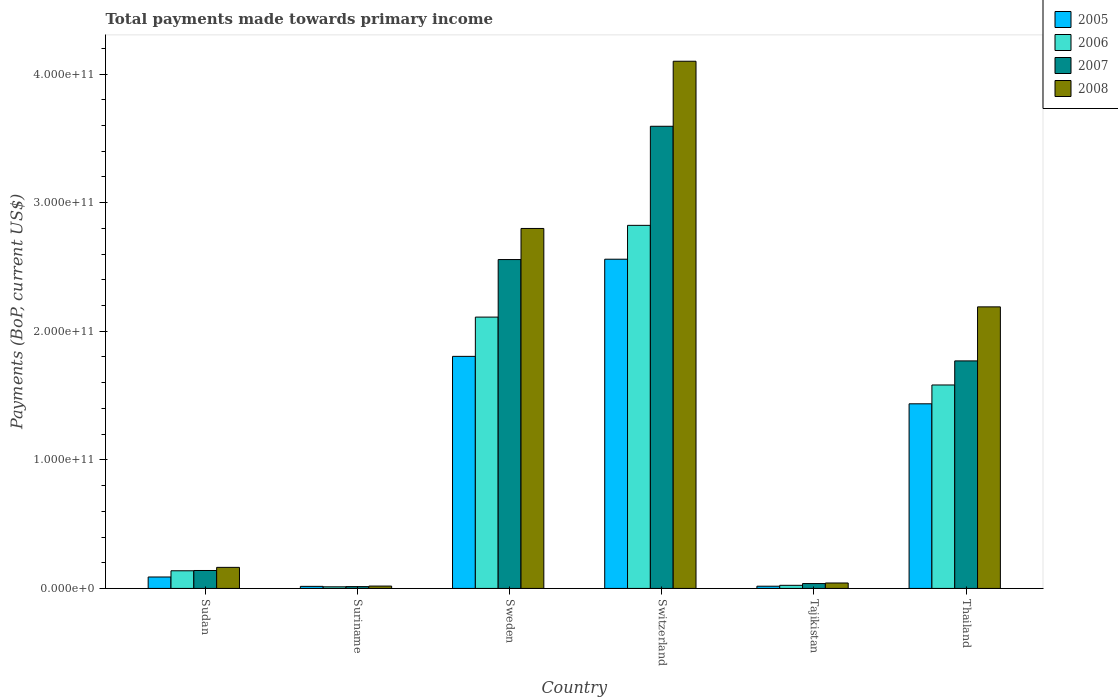Are the number of bars per tick equal to the number of legend labels?
Make the answer very short. Yes. Are the number of bars on each tick of the X-axis equal?
Provide a short and direct response. Yes. How many bars are there on the 2nd tick from the right?
Keep it short and to the point. 4. What is the label of the 4th group of bars from the left?
Ensure brevity in your answer.  Switzerland. In how many cases, is the number of bars for a given country not equal to the number of legend labels?
Your answer should be compact. 0. What is the total payments made towards primary income in 2006 in Tajikistan?
Ensure brevity in your answer.  2.43e+09. Across all countries, what is the maximum total payments made towards primary income in 2008?
Offer a very short reply. 4.10e+11. Across all countries, what is the minimum total payments made towards primary income in 2005?
Offer a terse response. 1.61e+09. In which country was the total payments made towards primary income in 2007 maximum?
Your answer should be compact. Switzerland. In which country was the total payments made towards primary income in 2006 minimum?
Provide a succinct answer. Suriname. What is the total total payments made towards primary income in 2007 in the graph?
Give a very brief answer. 8.11e+11. What is the difference between the total payments made towards primary income in 2008 in Sudan and that in Sweden?
Your response must be concise. -2.64e+11. What is the difference between the total payments made towards primary income in 2007 in Sudan and the total payments made towards primary income in 2006 in Tajikistan?
Keep it short and to the point. 1.15e+1. What is the average total payments made towards primary income in 2008 per country?
Make the answer very short. 1.55e+11. What is the difference between the total payments made towards primary income of/in 2005 and total payments made towards primary income of/in 2007 in Tajikistan?
Provide a short and direct response. -2.05e+09. In how many countries, is the total payments made towards primary income in 2008 greater than 360000000000 US$?
Ensure brevity in your answer.  1. What is the ratio of the total payments made towards primary income in 2005 in Sudan to that in Suriname?
Keep it short and to the point. 5.54. Is the total payments made towards primary income in 2006 in Sweden less than that in Switzerland?
Make the answer very short. Yes. Is the difference between the total payments made towards primary income in 2005 in Sudan and Tajikistan greater than the difference between the total payments made towards primary income in 2007 in Sudan and Tajikistan?
Ensure brevity in your answer.  No. What is the difference between the highest and the second highest total payments made towards primary income in 2008?
Ensure brevity in your answer.  1.30e+11. What is the difference between the highest and the lowest total payments made towards primary income in 2005?
Ensure brevity in your answer.  2.54e+11. Is the sum of the total payments made towards primary income in 2005 in Switzerland and Thailand greater than the maximum total payments made towards primary income in 2006 across all countries?
Your answer should be compact. Yes. What does the 4th bar from the left in Thailand represents?
Your answer should be compact. 2008. Is it the case that in every country, the sum of the total payments made towards primary income in 2005 and total payments made towards primary income in 2007 is greater than the total payments made towards primary income in 2008?
Keep it short and to the point. Yes. How many bars are there?
Offer a very short reply. 24. What is the difference between two consecutive major ticks on the Y-axis?
Give a very brief answer. 1.00e+11. Are the values on the major ticks of Y-axis written in scientific E-notation?
Your response must be concise. Yes. How are the legend labels stacked?
Your answer should be very brief. Vertical. What is the title of the graph?
Give a very brief answer. Total payments made towards primary income. Does "2000" appear as one of the legend labels in the graph?
Provide a succinct answer. No. What is the label or title of the Y-axis?
Give a very brief answer. Payments (BoP, current US$). What is the Payments (BoP, current US$) of 2005 in Sudan?
Your answer should be compact. 8.90e+09. What is the Payments (BoP, current US$) in 2006 in Sudan?
Your response must be concise. 1.37e+1. What is the Payments (BoP, current US$) of 2007 in Sudan?
Make the answer very short. 1.40e+1. What is the Payments (BoP, current US$) in 2008 in Sudan?
Your response must be concise. 1.64e+1. What is the Payments (BoP, current US$) in 2005 in Suriname?
Give a very brief answer. 1.61e+09. What is the Payments (BoP, current US$) in 2006 in Suriname?
Your answer should be very brief. 1.25e+09. What is the Payments (BoP, current US$) in 2007 in Suriname?
Your answer should be compact. 1.41e+09. What is the Payments (BoP, current US$) of 2008 in Suriname?
Give a very brief answer. 1.84e+09. What is the Payments (BoP, current US$) of 2005 in Sweden?
Your response must be concise. 1.80e+11. What is the Payments (BoP, current US$) of 2006 in Sweden?
Provide a short and direct response. 2.11e+11. What is the Payments (BoP, current US$) in 2007 in Sweden?
Your response must be concise. 2.56e+11. What is the Payments (BoP, current US$) in 2008 in Sweden?
Provide a short and direct response. 2.80e+11. What is the Payments (BoP, current US$) in 2005 in Switzerland?
Offer a very short reply. 2.56e+11. What is the Payments (BoP, current US$) in 2006 in Switzerland?
Ensure brevity in your answer.  2.82e+11. What is the Payments (BoP, current US$) in 2007 in Switzerland?
Keep it short and to the point. 3.59e+11. What is the Payments (BoP, current US$) of 2008 in Switzerland?
Your response must be concise. 4.10e+11. What is the Payments (BoP, current US$) of 2005 in Tajikistan?
Ensure brevity in your answer.  1.73e+09. What is the Payments (BoP, current US$) in 2006 in Tajikistan?
Offer a very short reply. 2.43e+09. What is the Payments (BoP, current US$) of 2007 in Tajikistan?
Provide a short and direct response. 3.78e+09. What is the Payments (BoP, current US$) in 2008 in Tajikistan?
Your answer should be compact. 4.23e+09. What is the Payments (BoP, current US$) in 2005 in Thailand?
Your response must be concise. 1.44e+11. What is the Payments (BoP, current US$) of 2006 in Thailand?
Offer a terse response. 1.58e+11. What is the Payments (BoP, current US$) of 2007 in Thailand?
Ensure brevity in your answer.  1.77e+11. What is the Payments (BoP, current US$) in 2008 in Thailand?
Give a very brief answer. 2.19e+11. Across all countries, what is the maximum Payments (BoP, current US$) in 2005?
Your response must be concise. 2.56e+11. Across all countries, what is the maximum Payments (BoP, current US$) in 2006?
Provide a succinct answer. 2.82e+11. Across all countries, what is the maximum Payments (BoP, current US$) in 2007?
Offer a terse response. 3.59e+11. Across all countries, what is the maximum Payments (BoP, current US$) of 2008?
Your answer should be very brief. 4.10e+11. Across all countries, what is the minimum Payments (BoP, current US$) in 2005?
Provide a succinct answer. 1.61e+09. Across all countries, what is the minimum Payments (BoP, current US$) in 2006?
Your answer should be compact. 1.25e+09. Across all countries, what is the minimum Payments (BoP, current US$) in 2007?
Provide a succinct answer. 1.41e+09. Across all countries, what is the minimum Payments (BoP, current US$) in 2008?
Make the answer very short. 1.84e+09. What is the total Payments (BoP, current US$) in 2005 in the graph?
Give a very brief answer. 5.92e+11. What is the total Payments (BoP, current US$) in 2006 in the graph?
Give a very brief answer. 6.69e+11. What is the total Payments (BoP, current US$) of 2007 in the graph?
Your response must be concise. 8.11e+11. What is the total Payments (BoP, current US$) in 2008 in the graph?
Keep it short and to the point. 9.31e+11. What is the difference between the Payments (BoP, current US$) in 2005 in Sudan and that in Suriname?
Offer a terse response. 7.29e+09. What is the difference between the Payments (BoP, current US$) of 2006 in Sudan and that in Suriname?
Provide a short and direct response. 1.25e+1. What is the difference between the Payments (BoP, current US$) in 2007 in Sudan and that in Suriname?
Your answer should be compact. 1.25e+1. What is the difference between the Payments (BoP, current US$) of 2008 in Sudan and that in Suriname?
Give a very brief answer. 1.45e+1. What is the difference between the Payments (BoP, current US$) of 2005 in Sudan and that in Sweden?
Provide a succinct answer. -1.72e+11. What is the difference between the Payments (BoP, current US$) in 2006 in Sudan and that in Sweden?
Your answer should be compact. -1.97e+11. What is the difference between the Payments (BoP, current US$) of 2007 in Sudan and that in Sweden?
Give a very brief answer. -2.42e+11. What is the difference between the Payments (BoP, current US$) of 2008 in Sudan and that in Sweden?
Make the answer very short. -2.64e+11. What is the difference between the Payments (BoP, current US$) of 2005 in Sudan and that in Switzerland?
Make the answer very short. -2.47e+11. What is the difference between the Payments (BoP, current US$) in 2006 in Sudan and that in Switzerland?
Give a very brief answer. -2.69e+11. What is the difference between the Payments (BoP, current US$) of 2007 in Sudan and that in Switzerland?
Provide a succinct answer. -3.45e+11. What is the difference between the Payments (BoP, current US$) in 2008 in Sudan and that in Switzerland?
Provide a short and direct response. -3.94e+11. What is the difference between the Payments (BoP, current US$) in 2005 in Sudan and that in Tajikistan?
Provide a succinct answer. 7.17e+09. What is the difference between the Payments (BoP, current US$) of 2006 in Sudan and that in Tajikistan?
Keep it short and to the point. 1.13e+1. What is the difference between the Payments (BoP, current US$) of 2007 in Sudan and that in Tajikistan?
Keep it short and to the point. 1.02e+1. What is the difference between the Payments (BoP, current US$) in 2008 in Sudan and that in Tajikistan?
Provide a succinct answer. 1.22e+1. What is the difference between the Payments (BoP, current US$) in 2005 in Sudan and that in Thailand?
Make the answer very short. -1.35e+11. What is the difference between the Payments (BoP, current US$) in 2006 in Sudan and that in Thailand?
Ensure brevity in your answer.  -1.44e+11. What is the difference between the Payments (BoP, current US$) in 2007 in Sudan and that in Thailand?
Your response must be concise. -1.63e+11. What is the difference between the Payments (BoP, current US$) in 2008 in Sudan and that in Thailand?
Provide a short and direct response. -2.03e+11. What is the difference between the Payments (BoP, current US$) in 2005 in Suriname and that in Sweden?
Your answer should be very brief. -1.79e+11. What is the difference between the Payments (BoP, current US$) of 2006 in Suriname and that in Sweden?
Offer a very short reply. -2.10e+11. What is the difference between the Payments (BoP, current US$) in 2007 in Suriname and that in Sweden?
Your answer should be very brief. -2.54e+11. What is the difference between the Payments (BoP, current US$) of 2008 in Suriname and that in Sweden?
Make the answer very short. -2.78e+11. What is the difference between the Payments (BoP, current US$) in 2005 in Suriname and that in Switzerland?
Ensure brevity in your answer.  -2.54e+11. What is the difference between the Payments (BoP, current US$) of 2006 in Suriname and that in Switzerland?
Provide a succinct answer. -2.81e+11. What is the difference between the Payments (BoP, current US$) of 2007 in Suriname and that in Switzerland?
Provide a short and direct response. -3.58e+11. What is the difference between the Payments (BoP, current US$) of 2008 in Suriname and that in Switzerland?
Provide a succinct answer. -4.08e+11. What is the difference between the Payments (BoP, current US$) of 2005 in Suriname and that in Tajikistan?
Ensure brevity in your answer.  -1.28e+08. What is the difference between the Payments (BoP, current US$) in 2006 in Suriname and that in Tajikistan?
Give a very brief answer. -1.17e+09. What is the difference between the Payments (BoP, current US$) in 2007 in Suriname and that in Tajikistan?
Your response must be concise. -2.37e+09. What is the difference between the Payments (BoP, current US$) in 2008 in Suriname and that in Tajikistan?
Provide a succinct answer. -2.39e+09. What is the difference between the Payments (BoP, current US$) in 2005 in Suriname and that in Thailand?
Keep it short and to the point. -1.42e+11. What is the difference between the Payments (BoP, current US$) in 2006 in Suriname and that in Thailand?
Your answer should be compact. -1.57e+11. What is the difference between the Payments (BoP, current US$) in 2007 in Suriname and that in Thailand?
Offer a terse response. -1.76e+11. What is the difference between the Payments (BoP, current US$) of 2008 in Suriname and that in Thailand?
Your answer should be very brief. -2.17e+11. What is the difference between the Payments (BoP, current US$) in 2005 in Sweden and that in Switzerland?
Keep it short and to the point. -7.56e+1. What is the difference between the Payments (BoP, current US$) of 2006 in Sweden and that in Switzerland?
Your answer should be very brief. -7.14e+1. What is the difference between the Payments (BoP, current US$) in 2007 in Sweden and that in Switzerland?
Your answer should be very brief. -1.04e+11. What is the difference between the Payments (BoP, current US$) in 2008 in Sweden and that in Switzerland?
Give a very brief answer. -1.30e+11. What is the difference between the Payments (BoP, current US$) of 2005 in Sweden and that in Tajikistan?
Your answer should be compact. 1.79e+11. What is the difference between the Payments (BoP, current US$) in 2006 in Sweden and that in Tajikistan?
Provide a short and direct response. 2.09e+11. What is the difference between the Payments (BoP, current US$) in 2007 in Sweden and that in Tajikistan?
Your answer should be compact. 2.52e+11. What is the difference between the Payments (BoP, current US$) in 2008 in Sweden and that in Tajikistan?
Provide a succinct answer. 2.76e+11. What is the difference between the Payments (BoP, current US$) in 2005 in Sweden and that in Thailand?
Your response must be concise. 3.69e+1. What is the difference between the Payments (BoP, current US$) of 2006 in Sweden and that in Thailand?
Your answer should be compact. 5.28e+1. What is the difference between the Payments (BoP, current US$) in 2007 in Sweden and that in Thailand?
Keep it short and to the point. 7.88e+1. What is the difference between the Payments (BoP, current US$) in 2008 in Sweden and that in Thailand?
Your answer should be compact. 6.10e+1. What is the difference between the Payments (BoP, current US$) in 2005 in Switzerland and that in Tajikistan?
Make the answer very short. 2.54e+11. What is the difference between the Payments (BoP, current US$) of 2006 in Switzerland and that in Tajikistan?
Provide a short and direct response. 2.80e+11. What is the difference between the Payments (BoP, current US$) of 2007 in Switzerland and that in Tajikistan?
Offer a very short reply. 3.56e+11. What is the difference between the Payments (BoP, current US$) of 2008 in Switzerland and that in Tajikistan?
Your response must be concise. 4.06e+11. What is the difference between the Payments (BoP, current US$) in 2005 in Switzerland and that in Thailand?
Your answer should be very brief. 1.12e+11. What is the difference between the Payments (BoP, current US$) of 2006 in Switzerland and that in Thailand?
Offer a very short reply. 1.24e+11. What is the difference between the Payments (BoP, current US$) of 2007 in Switzerland and that in Thailand?
Offer a terse response. 1.82e+11. What is the difference between the Payments (BoP, current US$) of 2008 in Switzerland and that in Thailand?
Give a very brief answer. 1.91e+11. What is the difference between the Payments (BoP, current US$) in 2005 in Tajikistan and that in Thailand?
Make the answer very short. -1.42e+11. What is the difference between the Payments (BoP, current US$) of 2006 in Tajikistan and that in Thailand?
Keep it short and to the point. -1.56e+11. What is the difference between the Payments (BoP, current US$) of 2007 in Tajikistan and that in Thailand?
Give a very brief answer. -1.73e+11. What is the difference between the Payments (BoP, current US$) in 2008 in Tajikistan and that in Thailand?
Ensure brevity in your answer.  -2.15e+11. What is the difference between the Payments (BoP, current US$) of 2005 in Sudan and the Payments (BoP, current US$) of 2006 in Suriname?
Your answer should be compact. 7.65e+09. What is the difference between the Payments (BoP, current US$) of 2005 in Sudan and the Payments (BoP, current US$) of 2007 in Suriname?
Your answer should be compact. 7.49e+09. What is the difference between the Payments (BoP, current US$) in 2005 in Sudan and the Payments (BoP, current US$) in 2008 in Suriname?
Give a very brief answer. 7.06e+09. What is the difference between the Payments (BoP, current US$) in 2006 in Sudan and the Payments (BoP, current US$) in 2007 in Suriname?
Keep it short and to the point. 1.23e+1. What is the difference between the Payments (BoP, current US$) of 2006 in Sudan and the Payments (BoP, current US$) of 2008 in Suriname?
Offer a very short reply. 1.19e+1. What is the difference between the Payments (BoP, current US$) of 2007 in Sudan and the Payments (BoP, current US$) of 2008 in Suriname?
Offer a terse response. 1.21e+1. What is the difference between the Payments (BoP, current US$) in 2005 in Sudan and the Payments (BoP, current US$) in 2006 in Sweden?
Give a very brief answer. -2.02e+11. What is the difference between the Payments (BoP, current US$) of 2005 in Sudan and the Payments (BoP, current US$) of 2007 in Sweden?
Offer a very short reply. -2.47e+11. What is the difference between the Payments (BoP, current US$) in 2005 in Sudan and the Payments (BoP, current US$) in 2008 in Sweden?
Make the answer very short. -2.71e+11. What is the difference between the Payments (BoP, current US$) of 2006 in Sudan and the Payments (BoP, current US$) of 2007 in Sweden?
Provide a succinct answer. -2.42e+11. What is the difference between the Payments (BoP, current US$) in 2006 in Sudan and the Payments (BoP, current US$) in 2008 in Sweden?
Give a very brief answer. -2.66e+11. What is the difference between the Payments (BoP, current US$) of 2007 in Sudan and the Payments (BoP, current US$) of 2008 in Sweden?
Offer a terse response. -2.66e+11. What is the difference between the Payments (BoP, current US$) in 2005 in Sudan and the Payments (BoP, current US$) in 2006 in Switzerland?
Provide a short and direct response. -2.73e+11. What is the difference between the Payments (BoP, current US$) of 2005 in Sudan and the Payments (BoP, current US$) of 2007 in Switzerland?
Your response must be concise. -3.51e+11. What is the difference between the Payments (BoP, current US$) in 2005 in Sudan and the Payments (BoP, current US$) in 2008 in Switzerland?
Provide a short and direct response. -4.01e+11. What is the difference between the Payments (BoP, current US$) in 2006 in Sudan and the Payments (BoP, current US$) in 2007 in Switzerland?
Your response must be concise. -3.46e+11. What is the difference between the Payments (BoP, current US$) in 2006 in Sudan and the Payments (BoP, current US$) in 2008 in Switzerland?
Offer a very short reply. -3.96e+11. What is the difference between the Payments (BoP, current US$) of 2007 in Sudan and the Payments (BoP, current US$) of 2008 in Switzerland?
Make the answer very short. -3.96e+11. What is the difference between the Payments (BoP, current US$) in 2005 in Sudan and the Payments (BoP, current US$) in 2006 in Tajikistan?
Keep it short and to the point. 6.47e+09. What is the difference between the Payments (BoP, current US$) in 2005 in Sudan and the Payments (BoP, current US$) in 2007 in Tajikistan?
Your answer should be very brief. 5.12e+09. What is the difference between the Payments (BoP, current US$) in 2005 in Sudan and the Payments (BoP, current US$) in 2008 in Tajikistan?
Give a very brief answer. 4.67e+09. What is the difference between the Payments (BoP, current US$) of 2006 in Sudan and the Payments (BoP, current US$) of 2007 in Tajikistan?
Give a very brief answer. 9.96e+09. What is the difference between the Payments (BoP, current US$) in 2006 in Sudan and the Payments (BoP, current US$) in 2008 in Tajikistan?
Give a very brief answer. 9.51e+09. What is the difference between the Payments (BoP, current US$) in 2007 in Sudan and the Payments (BoP, current US$) in 2008 in Tajikistan?
Give a very brief answer. 9.72e+09. What is the difference between the Payments (BoP, current US$) in 2005 in Sudan and the Payments (BoP, current US$) in 2006 in Thailand?
Give a very brief answer. -1.49e+11. What is the difference between the Payments (BoP, current US$) of 2005 in Sudan and the Payments (BoP, current US$) of 2007 in Thailand?
Offer a terse response. -1.68e+11. What is the difference between the Payments (BoP, current US$) of 2005 in Sudan and the Payments (BoP, current US$) of 2008 in Thailand?
Your answer should be very brief. -2.10e+11. What is the difference between the Payments (BoP, current US$) in 2006 in Sudan and the Payments (BoP, current US$) in 2007 in Thailand?
Your answer should be compact. -1.63e+11. What is the difference between the Payments (BoP, current US$) of 2006 in Sudan and the Payments (BoP, current US$) of 2008 in Thailand?
Your response must be concise. -2.05e+11. What is the difference between the Payments (BoP, current US$) in 2007 in Sudan and the Payments (BoP, current US$) in 2008 in Thailand?
Offer a very short reply. -2.05e+11. What is the difference between the Payments (BoP, current US$) in 2005 in Suriname and the Payments (BoP, current US$) in 2006 in Sweden?
Your answer should be very brief. -2.09e+11. What is the difference between the Payments (BoP, current US$) of 2005 in Suriname and the Payments (BoP, current US$) of 2007 in Sweden?
Make the answer very short. -2.54e+11. What is the difference between the Payments (BoP, current US$) in 2005 in Suriname and the Payments (BoP, current US$) in 2008 in Sweden?
Your answer should be very brief. -2.78e+11. What is the difference between the Payments (BoP, current US$) in 2006 in Suriname and the Payments (BoP, current US$) in 2007 in Sweden?
Provide a succinct answer. -2.55e+11. What is the difference between the Payments (BoP, current US$) of 2006 in Suriname and the Payments (BoP, current US$) of 2008 in Sweden?
Your answer should be compact. -2.79e+11. What is the difference between the Payments (BoP, current US$) in 2007 in Suriname and the Payments (BoP, current US$) in 2008 in Sweden?
Make the answer very short. -2.79e+11. What is the difference between the Payments (BoP, current US$) in 2005 in Suriname and the Payments (BoP, current US$) in 2006 in Switzerland?
Keep it short and to the point. -2.81e+11. What is the difference between the Payments (BoP, current US$) of 2005 in Suriname and the Payments (BoP, current US$) of 2007 in Switzerland?
Offer a terse response. -3.58e+11. What is the difference between the Payments (BoP, current US$) of 2005 in Suriname and the Payments (BoP, current US$) of 2008 in Switzerland?
Your response must be concise. -4.08e+11. What is the difference between the Payments (BoP, current US$) of 2006 in Suriname and the Payments (BoP, current US$) of 2007 in Switzerland?
Your response must be concise. -3.58e+11. What is the difference between the Payments (BoP, current US$) in 2006 in Suriname and the Payments (BoP, current US$) in 2008 in Switzerland?
Keep it short and to the point. -4.09e+11. What is the difference between the Payments (BoP, current US$) of 2007 in Suriname and the Payments (BoP, current US$) of 2008 in Switzerland?
Make the answer very short. -4.09e+11. What is the difference between the Payments (BoP, current US$) of 2005 in Suriname and the Payments (BoP, current US$) of 2006 in Tajikistan?
Provide a short and direct response. -8.20e+08. What is the difference between the Payments (BoP, current US$) of 2005 in Suriname and the Payments (BoP, current US$) of 2007 in Tajikistan?
Provide a short and direct response. -2.17e+09. What is the difference between the Payments (BoP, current US$) in 2005 in Suriname and the Payments (BoP, current US$) in 2008 in Tajikistan?
Provide a succinct answer. -2.62e+09. What is the difference between the Payments (BoP, current US$) in 2006 in Suriname and the Payments (BoP, current US$) in 2007 in Tajikistan?
Keep it short and to the point. -2.53e+09. What is the difference between the Payments (BoP, current US$) in 2006 in Suriname and the Payments (BoP, current US$) in 2008 in Tajikistan?
Offer a very short reply. -2.98e+09. What is the difference between the Payments (BoP, current US$) of 2007 in Suriname and the Payments (BoP, current US$) of 2008 in Tajikistan?
Provide a succinct answer. -2.82e+09. What is the difference between the Payments (BoP, current US$) of 2005 in Suriname and the Payments (BoP, current US$) of 2006 in Thailand?
Your response must be concise. -1.57e+11. What is the difference between the Payments (BoP, current US$) in 2005 in Suriname and the Payments (BoP, current US$) in 2007 in Thailand?
Make the answer very short. -1.75e+11. What is the difference between the Payments (BoP, current US$) of 2005 in Suriname and the Payments (BoP, current US$) of 2008 in Thailand?
Keep it short and to the point. -2.17e+11. What is the difference between the Payments (BoP, current US$) in 2006 in Suriname and the Payments (BoP, current US$) in 2007 in Thailand?
Keep it short and to the point. -1.76e+11. What is the difference between the Payments (BoP, current US$) of 2006 in Suriname and the Payments (BoP, current US$) of 2008 in Thailand?
Keep it short and to the point. -2.18e+11. What is the difference between the Payments (BoP, current US$) in 2007 in Suriname and the Payments (BoP, current US$) in 2008 in Thailand?
Offer a terse response. -2.18e+11. What is the difference between the Payments (BoP, current US$) in 2005 in Sweden and the Payments (BoP, current US$) in 2006 in Switzerland?
Provide a short and direct response. -1.02e+11. What is the difference between the Payments (BoP, current US$) of 2005 in Sweden and the Payments (BoP, current US$) of 2007 in Switzerland?
Your answer should be compact. -1.79e+11. What is the difference between the Payments (BoP, current US$) of 2005 in Sweden and the Payments (BoP, current US$) of 2008 in Switzerland?
Keep it short and to the point. -2.30e+11. What is the difference between the Payments (BoP, current US$) in 2006 in Sweden and the Payments (BoP, current US$) in 2007 in Switzerland?
Make the answer very short. -1.48e+11. What is the difference between the Payments (BoP, current US$) of 2006 in Sweden and the Payments (BoP, current US$) of 2008 in Switzerland?
Make the answer very short. -1.99e+11. What is the difference between the Payments (BoP, current US$) in 2007 in Sweden and the Payments (BoP, current US$) in 2008 in Switzerland?
Ensure brevity in your answer.  -1.54e+11. What is the difference between the Payments (BoP, current US$) of 2005 in Sweden and the Payments (BoP, current US$) of 2006 in Tajikistan?
Provide a succinct answer. 1.78e+11. What is the difference between the Payments (BoP, current US$) in 2005 in Sweden and the Payments (BoP, current US$) in 2007 in Tajikistan?
Give a very brief answer. 1.77e+11. What is the difference between the Payments (BoP, current US$) of 2005 in Sweden and the Payments (BoP, current US$) of 2008 in Tajikistan?
Keep it short and to the point. 1.76e+11. What is the difference between the Payments (BoP, current US$) of 2006 in Sweden and the Payments (BoP, current US$) of 2007 in Tajikistan?
Make the answer very short. 2.07e+11. What is the difference between the Payments (BoP, current US$) of 2006 in Sweden and the Payments (BoP, current US$) of 2008 in Tajikistan?
Offer a terse response. 2.07e+11. What is the difference between the Payments (BoP, current US$) of 2007 in Sweden and the Payments (BoP, current US$) of 2008 in Tajikistan?
Make the answer very short. 2.52e+11. What is the difference between the Payments (BoP, current US$) in 2005 in Sweden and the Payments (BoP, current US$) in 2006 in Thailand?
Make the answer very short. 2.23e+1. What is the difference between the Payments (BoP, current US$) in 2005 in Sweden and the Payments (BoP, current US$) in 2007 in Thailand?
Provide a short and direct response. 3.53e+09. What is the difference between the Payments (BoP, current US$) of 2005 in Sweden and the Payments (BoP, current US$) of 2008 in Thailand?
Your response must be concise. -3.85e+1. What is the difference between the Payments (BoP, current US$) in 2006 in Sweden and the Payments (BoP, current US$) in 2007 in Thailand?
Ensure brevity in your answer.  3.41e+1. What is the difference between the Payments (BoP, current US$) of 2006 in Sweden and the Payments (BoP, current US$) of 2008 in Thailand?
Offer a very short reply. -7.96e+09. What is the difference between the Payments (BoP, current US$) of 2007 in Sweden and the Payments (BoP, current US$) of 2008 in Thailand?
Keep it short and to the point. 3.68e+1. What is the difference between the Payments (BoP, current US$) in 2005 in Switzerland and the Payments (BoP, current US$) in 2006 in Tajikistan?
Your answer should be compact. 2.54e+11. What is the difference between the Payments (BoP, current US$) in 2005 in Switzerland and the Payments (BoP, current US$) in 2007 in Tajikistan?
Ensure brevity in your answer.  2.52e+11. What is the difference between the Payments (BoP, current US$) in 2005 in Switzerland and the Payments (BoP, current US$) in 2008 in Tajikistan?
Keep it short and to the point. 2.52e+11. What is the difference between the Payments (BoP, current US$) in 2006 in Switzerland and the Payments (BoP, current US$) in 2007 in Tajikistan?
Your answer should be very brief. 2.79e+11. What is the difference between the Payments (BoP, current US$) of 2006 in Switzerland and the Payments (BoP, current US$) of 2008 in Tajikistan?
Provide a short and direct response. 2.78e+11. What is the difference between the Payments (BoP, current US$) of 2007 in Switzerland and the Payments (BoP, current US$) of 2008 in Tajikistan?
Offer a terse response. 3.55e+11. What is the difference between the Payments (BoP, current US$) in 2005 in Switzerland and the Payments (BoP, current US$) in 2006 in Thailand?
Offer a terse response. 9.78e+1. What is the difference between the Payments (BoP, current US$) of 2005 in Switzerland and the Payments (BoP, current US$) of 2007 in Thailand?
Your answer should be very brief. 7.91e+1. What is the difference between the Payments (BoP, current US$) in 2005 in Switzerland and the Payments (BoP, current US$) in 2008 in Thailand?
Provide a succinct answer. 3.71e+1. What is the difference between the Payments (BoP, current US$) of 2006 in Switzerland and the Payments (BoP, current US$) of 2007 in Thailand?
Offer a terse response. 1.05e+11. What is the difference between the Payments (BoP, current US$) of 2006 in Switzerland and the Payments (BoP, current US$) of 2008 in Thailand?
Ensure brevity in your answer.  6.34e+1. What is the difference between the Payments (BoP, current US$) of 2007 in Switzerland and the Payments (BoP, current US$) of 2008 in Thailand?
Offer a terse response. 1.40e+11. What is the difference between the Payments (BoP, current US$) in 2005 in Tajikistan and the Payments (BoP, current US$) in 2006 in Thailand?
Provide a succinct answer. -1.57e+11. What is the difference between the Payments (BoP, current US$) of 2005 in Tajikistan and the Payments (BoP, current US$) of 2007 in Thailand?
Offer a terse response. -1.75e+11. What is the difference between the Payments (BoP, current US$) of 2005 in Tajikistan and the Payments (BoP, current US$) of 2008 in Thailand?
Provide a succinct answer. -2.17e+11. What is the difference between the Payments (BoP, current US$) of 2006 in Tajikistan and the Payments (BoP, current US$) of 2007 in Thailand?
Give a very brief answer. -1.75e+11. What is the difference between the Payments (BoP, current US$) in 2006 in Tajikistan and the Payments (BoP, current US$) in 2008 in Thailand?
Give a very brief answer. -2.17e+11. What is the difference between the Payments (BoP, current US$) of 2007 in Tajikistan and the Payments (BoP, current US$) of 2008 in Thailand?
Ensure brevity in your answer.  -2.15e+11. What is the average Payments (BoP, current US$) in 2005 per country?
Your answer should be very brief. 9.87e+1. What is the average Payments (BoP, current US$) of 2006 per country?
Your answer should be compact. 1.12e+11. What is the average Payments (BoP, current US$) of 2007 per country?
Provide a succinct answer. 1.35e+11. What is the average Payments (BoP, current US$) of 2008 per country?
Offer a very short reply. 1.55e+11. What is the difference between the Payments (BoP, current US$) in 2005 and Payments (BoP, current US$) in 2006 in Sudan?
Offer a terse response. -4.84e+09. What is the difference between the Payments (BoP, current US$) in 2005 and Payments (BoP, current US$) in 2007 in Sudan?
Provide a succinct answer. -5.05e+09. What is the difference between the Payments (BoP, current US$) of 2005 and Payments (BoP, current US$) of 2008 in Sudan?
Provide a succinct answer. -7.49e+09. What is the difference between the Payments (BoP, current US$) in 2006 and Payments (BoP, current US$) in 2007 in Sudan?
Ensure brevity in your answer.  -2.10e+08. What is the difference between the Payments (BoP, current US$) in 2006 and Payments (BoP, current US$) in 2008 in Sudan?
Provide a succinct answer. -2.64e+09. What is the difference between the Payments (BoP, current US$) in 2007 and Payments (BoP, current US$) in 2008 in Sudan?
Provide a succinct answer. -2.43e+09. What is the difference between the Payments (BoP, current US$) in 2005 and Payments (BoP, current US$) in 2006 in Suriname?
Keep it short and to the point. 3.54e+08. What is the difference between the Payments (BoP, current US$) in 2005 and Payments (BoP, current US$) in 2007 in Suriname?
Give a very brief answer. 1.96e+08. What is the difference between the Payments (BoP, current US$) of 2005 and Payments (BoP, current US$) of 2008 in Suriname?
Your response must be concise. -2.30e+08. What is the difference between the Payments (BoP, current US$) of 2006 and Payments (BoP, current US$) of 2007 in Suriname?
Offer a very short reply. -1.58e+08. What is the difference between the Payments (BoP, current US$) of 2006 and Payments (BoP, current US$) of 2008 in Suriname?
Your response must be concise. -5.84e+08. What is the difference between the Payments (BoP, current US$) in 2007 and Payments (BoP, current US$) in 2008 in Suriname?
Your answer should be very brief. -4.27e+08. What is the difference between the Payments (BoP, current US$) of 2005 and Payments (BoP, current US$) of 2006 in Sweden?
Offer a very short reply. -3.05e+1. What is the difference between the Payments (BoP, current US$) of 2005 and Payments (BoP, current US$) of 2007 in Sweden?
Make the answer very short. -7.53e+1. What is the difference between the Payments (BoP, current US$) in 2005 and Payments (BoP, current US$) in 2008 in Sweden?
Your answer should be very brief. -9.95e+1. What is the difference between the Payments (BoP, current US$) of 2006 and Payments (BoP, current US$) of 2007 in Sweden?
Your answer should be very brief. -4.48e+1. What is the difference between the Payments (BoP, current US$) in 2006 and Payments (BoP, current US$) in 2008 in Sweden?
Give a very brief answer. -6.89e+1. What is the difference between the Payments (BoP, current US$) of 2007 and Payments (BoP, current US$) of 2008 in Sweden?
Offer a terse response. -2.42e+1. What is the difference between the Payments (BoP, current US$) of 2005 and Payments (BoP, current US$) of 2006 in Switzerland?
Your answer should be compact. -2.63e+1. What is the difference between the Payments (BoP, current US$) in 2005 and Payments (BoP, current US$) in 2007 in Switzerland?
Your answer should be very brief. -1.03e+11. What is the difference between the Payments (BoP, current US$) in 2005 and Payments (BoP, current US$) in 2008 in Switzerland?
Your answer should be very brief. -1.54e+11. What is the difference between the Payments (BoP, current US$) of 2006 and Payments (BoP, current US$) of 2007 in Switzerland?
Your answer should be compact. -7.71e+1. What is the difference between the Payments (BoP, current US$) of 2006 and Payments (BoP, current US$) of 2008 in Switzerland?
Give a very brief answer. -1.28e+11. What is the difference between the Payments (BoP, current US$) of 2007 and Payments (BoP, current US$) of 2008 in Switzerland?
Provide a succinct answer. -5.06e+1. What is the difference between the Payments (BoP, current US$) of 2005 and Payments (BoP, current US$) of 2006 in Tajikistan?
Provide a succinct answer. -6.93e+08. What is the difference between the Payments (BoP, current US$) in 2005 and Payments (BoP, current US$) in 2007 in Tajikistan?
Make the answer very short. -2.05e+09. What is the difference between the Payments (BoP, current US$) of 2005 and Payments (BoP, current US$) of 2008 in Tajikistan?
Offer a terse response. -2.49e+09. What is the difference between the Payments (BoP, current US$) in 2006 and Payments (BoP, current US$) in 2007 in Tajikistan?
Provide a short and direct response. -1.35e+09. What is the difference between the Payments (BoP, current US$) in 2006 and Payments (BoP, current US$) in 2008 in Tajikistan?
Keep it short and to the point. -1.80e+09. What is the difference between the Payments (BoP, current US$) in 2007 and Payments (BoP, current US$) in 2008 in Tajikistan?
Provide a succinct answer. -4.47e+08. What is the difference between the Payments (BoP, current US$) of 2005 and Payments (BoP, current US$) of 2006 in Thailand?
Offer a very short reply. -1.46e+1. What is the difference between the Payments (BoP, current US$) in 2005 and Payments (BoP, current US$) in 2007 in Thailand?
Your answer should be very brief. -3.34e+1. What is the difference between the Payments (BoP, current US$) of 2005 and Payments (BoP, current US$) of 2008 in Thailand?
Provide a succinct answer. -7.54e+1. What is the difference between the Payments (BoP, current US$) in 2006 and Payments (BoP, current US$) in 2007 in Thailand?
Offer a terse response. -1.87e+1. What is the difference between the Payments (BoP, current US$) of 2006 and Payments (BoP, current US$) of 2008 in Thailand?
Your answer should be very brief. -6.08e+1. What is the difference between the Payments (BoP, current US$) in 2007 and Payments (BoP, current US$) in 2008 in Thailand?
Offer a terse response. -4.20e+1. What is the ratio of the Payments (BoP, current US$) of 2005 in Sudan to that in Suriname?
Your answer should be very brief. 5.54. What is the ratio of the Payments (BoP, current US$) of 2006 in Sudan to that in Suriname?
Make the answer very short. 10.98. What is the ratio of the Payments (BoP, current US$) of 2007 in Sudan to that in Suriname?
Your answer should be compact. 9.9. What is the ratio of the Payments (BoP, current US$) of 2008 in Sudan to that in Suriname?
Provide a short and direct response. 8.93. What is the ratio of the Payments (BoP, current US$) of 2005 in Sudan to that in Sweden?
Make the answer very short. 0.05. What is the ratio of the Payments (BoP, current US$) of 2006 in Sudan to that in Sweden?
Offer a very short reply. 0.07. What is the ratio of the Payments (BoP, current US$) of 2007 in Sudan to that in Sweden?
Your response must be concise. 0.05. What is the ratio of the Payments (BoP, current US$) in 2008 in Sudan to that in Sweden?
Offer a terse response. 0.06. What is the ratio of the Payments (BoP, current US$) in 2005 in Sudan to that in Switzerland?
Offer a very short reply. 0.03. What is the ratio of the Payments (BoP, current US$) of 2006 in Sudan to that in Switzerland?
Keep it short and to the point. 0.05. What is the ratio of the Payments (BoP, current US$) in 2007 in Sudan to that in Switzerland?
Provide a short and direct response. 0.04. What is the ratio of the Payments (BoP, current US$) in 2008 in Sudan to that in Switzerland?
Your answer should be compact. 0.04. What is the ratio of the Payments (BoP, current US$) of 2005 in Sudan to that in Tajikistan?
Give a very brief answer. 5.14. What is the ratio of the Payments (BoP, current US$) of 2006 in Sudan to that in Tajikistan?
Your response must be concise. 5.67. What is the ratio of the Payments (BoP, current US$) of 2007 in Sudan to that in Tajikistan?
Ensure brevity in your answer.  3.69. What is the ratio of the Payments (BoP, current US$) of 2008 in Sudan to that in Tajikistan?
Provide a short and direct response. 3.88. What is the ratio of the Payments (BoP, current US$) in 2005 in Sudan to that in Thailand?
Ensure brevity in your answer.  0.06. What is the ratio of the Payments (BoP, current US$) in 2006 in Sudan to that in Thailand?
Provide a succinct answer. 0.09. What is the ratio of the Payments (BoP, current US$) in 2007 in Sudan to that in Thailand?
Provide a short and direct response. 0.08. What is the ratio of the Payments (BoP, current US$) of 2008 in Sudan to that in Thailand?
Provide a succinct answer. 0.07. What is the ratio of the Payments (BoP, current US$) of 2005 in Suriname to that in Sweden?
Make the answer very short. 0.01. What is the ratio of the Payments (BoP, current US$) in 2006 in Suriname to that in Sweden?
Your answer should be compact. 0.01. What is the ratio of the Payments (BoP, current US$) in 2007 in Suriname to that in Sweden?
Offer a very short reply. 0.01. What is the ratio of the Payments (BoP, current US$) in 2008 in Suriname to that in Sweden?
Provide a succinct answer. 0.01. What is the ratio of the Payments (BoP, current US$) in 2005 in Suriname to that in Switzerland?
Offer a very short reply. 0.01. What is the ratio of the Payments (BoP, current US$) of 2006 in Suriname to that in Switzerland?
Your answer should be compact. 0. What is the ratio of the Payments (BoP, current US$) of 2007 in Suriname to that in Switzerland?
Your answer should be very brief. 0. What is the ratio of the Payments (BoP, current US$) in 2008 in Suriname to that in Switzerland?
Ensure brevity in your answer.  0. What is the ratio of the Payments (BoP, current US$) in 2005 in Suriname to that in Tajikistan?
Keep it short and to the point. 0.93. What is the ratio of the Payments (BoP, current US$) in 2006 in Suriname to that in Tajikistan?
Provide a succinct answer. 0.52. What is the ratio of the Payments (BoP, current US$) of 2007 in Suriname to that in Tajikistan?
Your answer should be very brief. 0.37. What is the ratio of the Payments (BoP, current US$) in 2008 in Suriname to that in Tajikistan?
Offer a terse response. 0.43. What is the ratio of the Payments (BoP, current US$) in 2005 in Suriname to that in Thailand?
Ensure brevity in your answer.  0.01. What is the ratio of the Payments (BoP, current US$) of 2006 in Suriname to that in Thailand?
Offer a very short reply. 0.01. What is the ratio of the Payments (BoP, current US$) in 2007 in Suriname to that in Thailand?
Provide a succinct answer. 0.01. What is the ratio of the Payments (BoP, current US$) in 2008 in Suriname to that in Thailand?
Ensure brevity in your answer.  0.01. What is the ratio of the Payments (BoP, current US$) of 2005 in Sweden to that in Switzerland?
Your response must be concise. 0.7. What is the ratio of the Payments (BoP, current US$) of 2006 in Sweden to that in Switzerland?
Ensure brevity in your answer.  0.75. What is the ratio of the Payments (BoP, current US$) in 2007 in Sweden to that in Switzerland?
Keep it short and to the point. 0.71. What is the ratio of the Payments (BoP, current US$) of 2008 in Sweden to that in Switzerland?
Provide a short and direct response. 0.68. What is the ratio of the Payments (BoP, current US$) in 2005 in Sweden to that in Tajikistan?
Your answer should be very brief. 104.16. What is the ratio of the Payments (BoP, current US$) in 2006 in Sweden to that in Tajikistan?
Give a very brief answer. 87.01. What is the ratio of the Payments (BoP, current US$) of 2007 in Sweden to that in Tajikistan?
Your response must be concise. 67.66. What is the ratio of the Payments (BoP, current US$) in 2008 in Sweden to that in Tajikistan?
Offer a very short reply. 66.24. What is the ratio of the Payments (BoP, current US$) in 2005 in Sweden to that in Thailand?
Provide a succinct answer. 1.26. What is the ratio of the Payments (BoP, current US$) of 2006 in Sweden to that in Thailand?
Give a very brief answer. 1.33. What is the ratio of the Payments (BoP, current US$) in 2007 in Sweden to that in Thailand?
Offer a very short reply. 1.45. What is the ratio of the Payments (BoP, current US$) of 2008 in Sweden to that in Thailand?
Keep it short and to the point. 1.28. What is the ratio of the Payments (BoP, current US$) in 2005 in Switzerland to that in Tajikistan?
Ensure brevity in your answer.  147.77. What is the ratio of the Payments (BoP, current US$) in 2006 in Switzerland to that in Tajikistan?
Offer a very short reply. 116.43. What is the ratio of the Payments (BoP, current US$) in 2007 in Switzerland to that in Tajikistan?
Offer a terse response. 95.09. What is the ratio of the Payments (BoP, current US$) in 2008 in Switzerland to that in Tajikistan?
Give a very brief answer. 97. What is the ratio of the Payments (BoP, current US$) in 2005 in Switzerland to that in Thailand?
Your response must be concise. 1.78. What is the ratio of the Payments (BoP, current US$) in 2006 in Switzerland to that in Thailand?
Offer a terse response. 1.78. What is the ratio of the Payments (BoP, current US$) of 2007 in Switzerland to that in Thailand?
Your answer should be very brief. 2.03. What is the ratio of the Payments (BoP, current US$) in 2008 in Switzerland to that in Thailand?
Your answer should be compact. 1.87. What is the ratio of the Payments (BoP, current US$) of 2005 in Tajikistan to that in Thailand?
Your response must be concise. 0.01. What is the ratio of the Payments (BoP, current US$) of 2006 in Tajikistan to that in Thailand?
Provide a succinct answer. 0.02. What is the ratio of the Payments (BoP, current US$) in 2007 in Tajikistan to that in Thailand?
Ensure brevity in your answer.  0.02. What is the ratio of the Payments (BoP, current US$) in 2008 in Tajikistan to that in Thailand?
Your answer should be very brief. 0.02. What is the difference between the highest and the second highest Payments (BoP, current US$) of 2005?
Your answer should be compact. 7.56e+1. What is the difference between the highest and the second highest Payments (BoP, current US$) of 2006?
Your answer should be compact. 7.14e+1. What is the difference between the highest and the second highest Payments (BoP, current US$) of 2007?
Provide a short and direct response. 1.04e+11. What is the difference between the highest and the second highest Payments (BoP, current US$) of 2008?
Your response must be concise. 1.30e+11. What is the difference between the highest and the lowest Payments (BoP, current US$) in 2005?
Your answer should be compact. 2.54e+11. What is the difference between the highest and the lowest Payments (BoP, current US$) of 2006?
Offer a very short reply. 2.81e+11. What is the difference between the highest and the lowest Payments (BoP, current US$) in 2007?
Make the answer very short. 3.58e+11. What is the difference between the highest and the lowest Payments (BoP, current US$) in 2008?
Provide a short and direct response. 4.08e+11. 